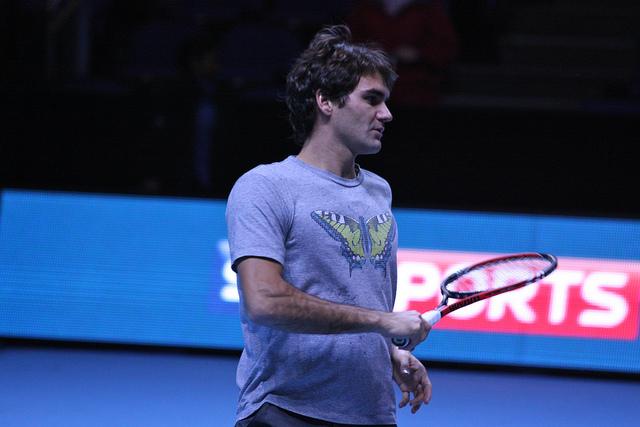What is the athlete doing?
Be succinct. Playing tennis. What sport is this?
Be succinct. Tennis. What is the dude holding?
Concise answer only. Tennis racket. What color is the wall?
Short answer required. Blue. Which hand is higher in the picture?
Keep it brief. Right. What is he holding?
Keep it brief. Tennis racket. How is the man dressed?
Short answer required. T shirt. Is he athletic?
Keep it brief. Yes. What sport does this person play?
Short answer required. Tennis. What is on the man's shirt?
Write a very short answer. Butterfly. What's on the man's shirt?
Keep it brief. Butterfly. Who is the sponsor of this event?
Concise answer only. Sports. What is yellow in the photo?
Quick response, please. Butterfly. IS the man wearing a hat?
Write a very short answer. No. 